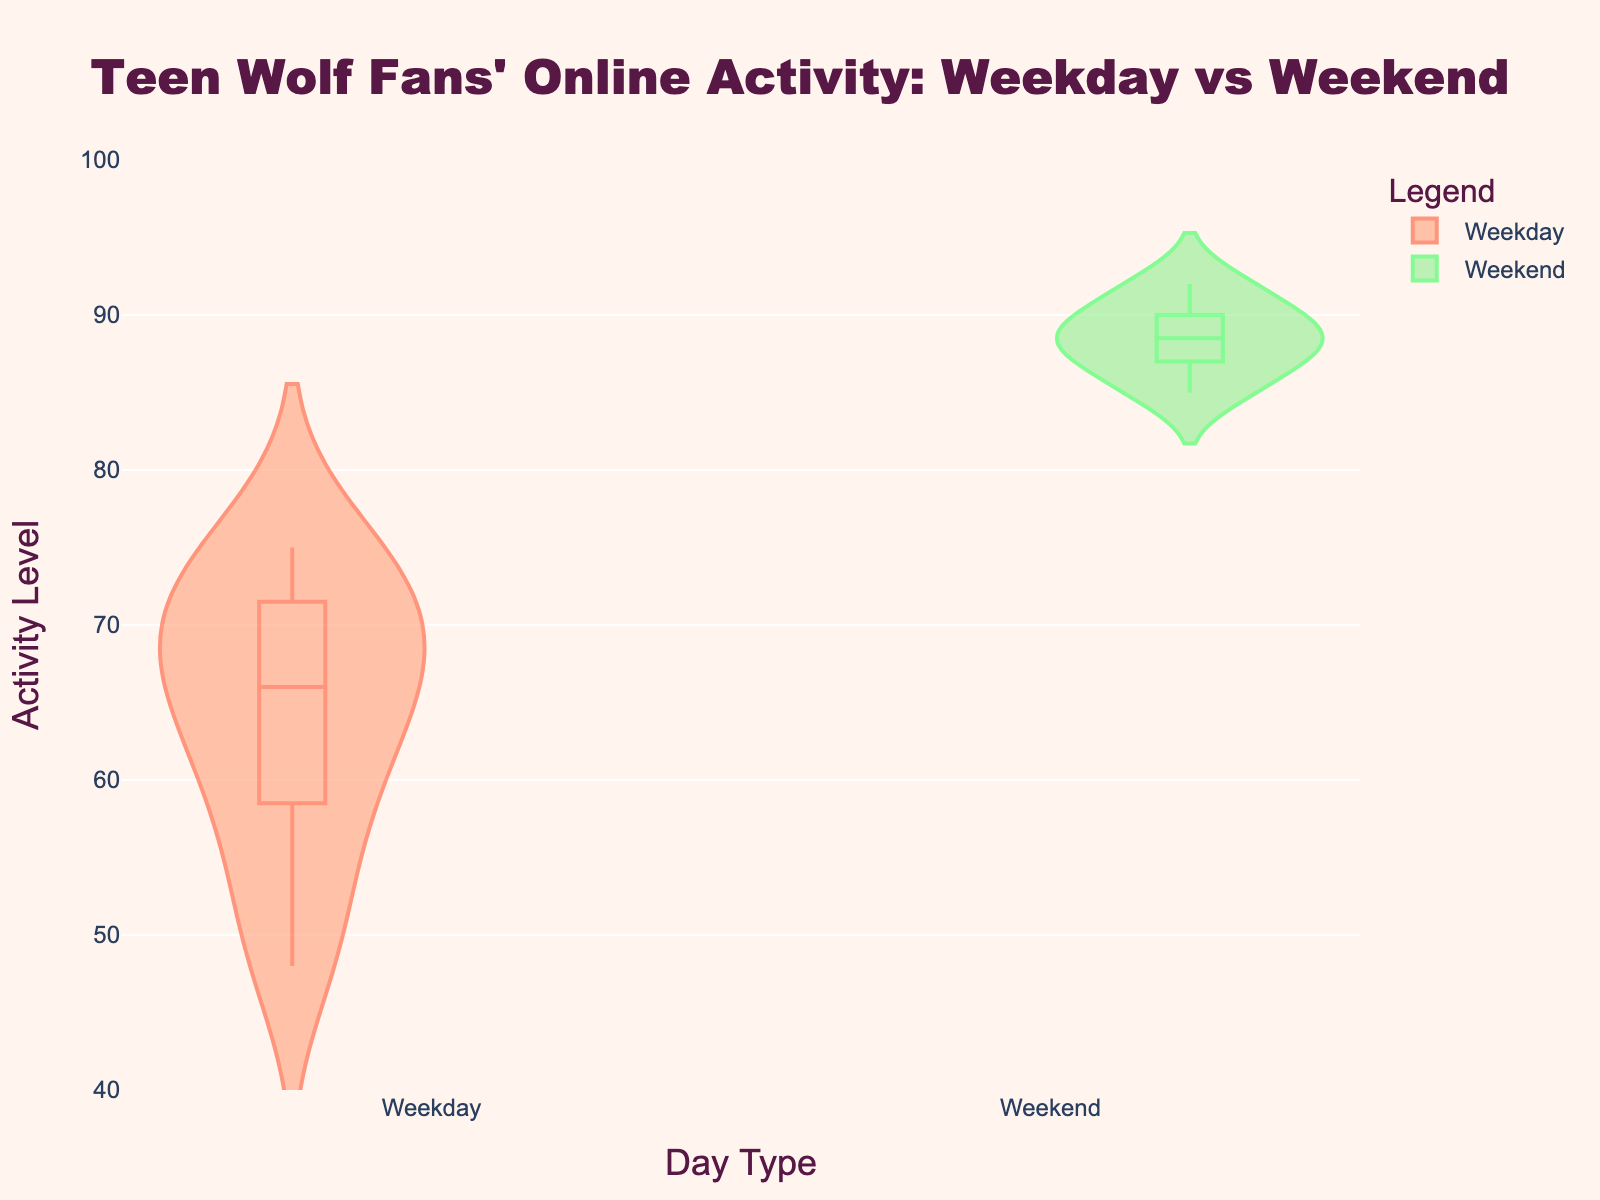What's the title of the figure? The title is often displayed at the top of the figure and it summarizes the main idea being presented. In this case, it is, "Teen Wolf Fans' Online Activity: Weekday vs Weekend".
Answer: Teen Wolf Fans' Online Activity: Weekday vs Weekend What does the y-axis represent in the figure? The y-axis typically represents the variable being measured. Here, the label indicates it is displaying "Activity Level".
Answer: Activity Level How are weekdays and weekends visually differentiated in the figure? In the figure, weekdays and weekends are differentiated using different colors. Weekday data is colored in shades of orange and red, while weekend data is in shades of green.
Answer: Different colors: orange/red for weekdays and green for weekends What is the median Activity Level for weekdays? The median can be approximated by looking at the point where the bulk of the violin plot's width is centered around. The weekday violin plot's median appears at approximately the value of 65.
Answer: 65 What is the approximate range of Activity Levels during weekdays? The range can be estimated by examining the vertical extent of the violin plot for weekdays. It appears to span roughly from 48 to 75.
Answer: 48 to 75 Which has a higher average Activity Level, weekdays or weekends? To compare the averages, one must observe the central tendency and width concentration of each violin plot. The weekend plot is centered higher compared to the weekday plot, indicating a higher average.
Answer: Weekends Is there any overlap in the Activity Level distributions of weekdays and weekends? Overlap can be seen by noting where the two violin plots intersect along the y-axis. There is an overlap around the Activity Levels from approximately 65 to 75.
Answer: Yes, around 65 to 75 What explains the large y-axis values in weekend activity compared to weekday activity? This can be attributed to the higher Activity Levels during weekends, as indicated by the maximum weekend values reaching up to 92 compared to 75 for weekdays.
Answer: Higher Activity Levels on weekends What is the maximum Activity Level indicated for weekends? The maximum is found at the topmost point of the weekend violin plot. It is indicated by the highest value, which is at 92.
Answer: 92 Are there any outliers visible in the weekday Activity Level plot? Outliers would be points that fall far outside the general width of the plot. Here, there are no visually evident outliers in the weekday Activity Level distribution.
Answer: No 